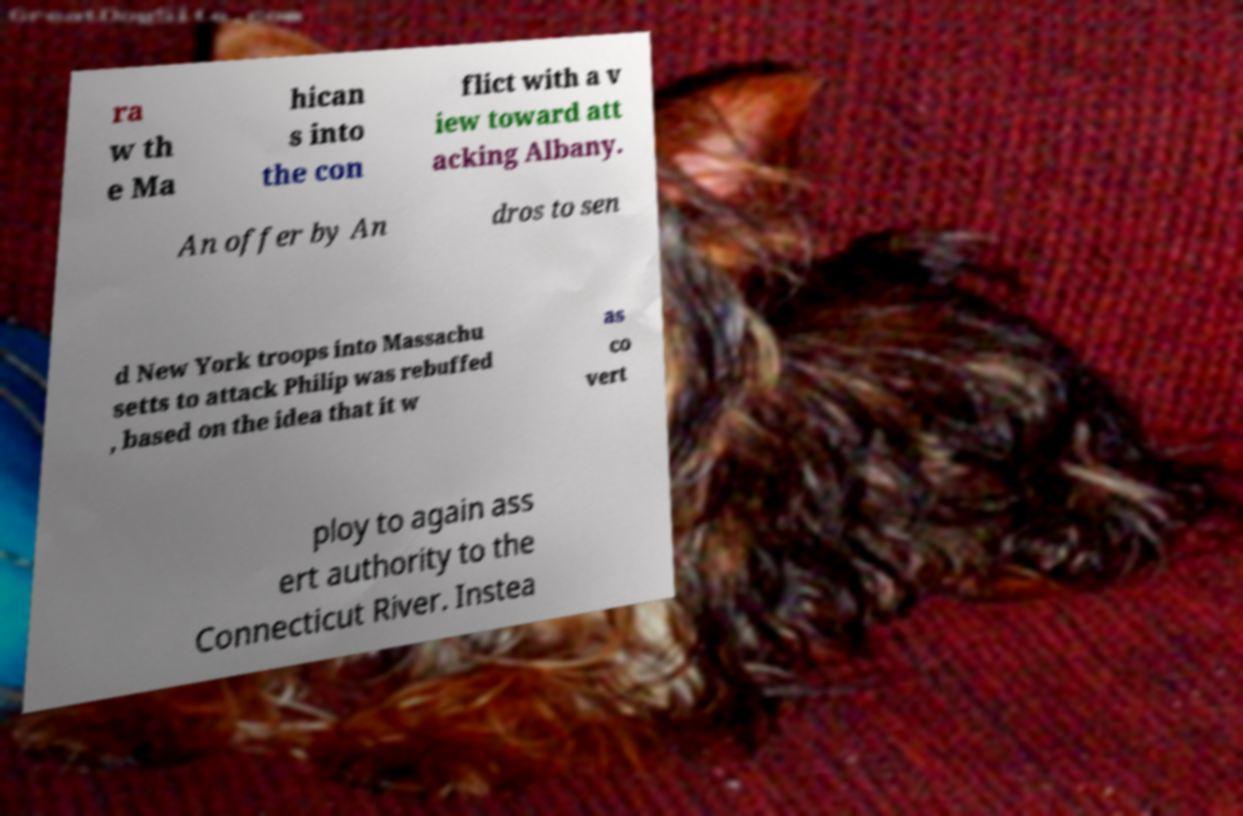There's text embedded in this image that I need extracted. Can you transcribe it verbatim? ra w th e Ma hican s into the con flict with a v iew toward att acking Albany. An offer by An dros to sen d New York troops into Massachu setts to attack Philip was rebuffed , based on the idea that it w as co vert ploy to again ass ert authority to the Connecticut River. Instea 